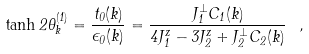<formula> <loc_0><loc_0><loc_500><loc_500>\tanh 2 \theta _ { k } ^ { ( 1 ) } = \frac { t _ { 0 } ( { k } ) } { \epsilon _ { 0 } ( { k } ) } = \frac { J _ { 1 } ^ { \perp } C _ { 1 } ( { k } ) } { 4 J _ { 1 } ^ { z } - 3 J _ { 2 } ^ { z } + J _ { 2 } ^ { \perp } C _ { 2 } ( { k } ) } \ ,</formula> 